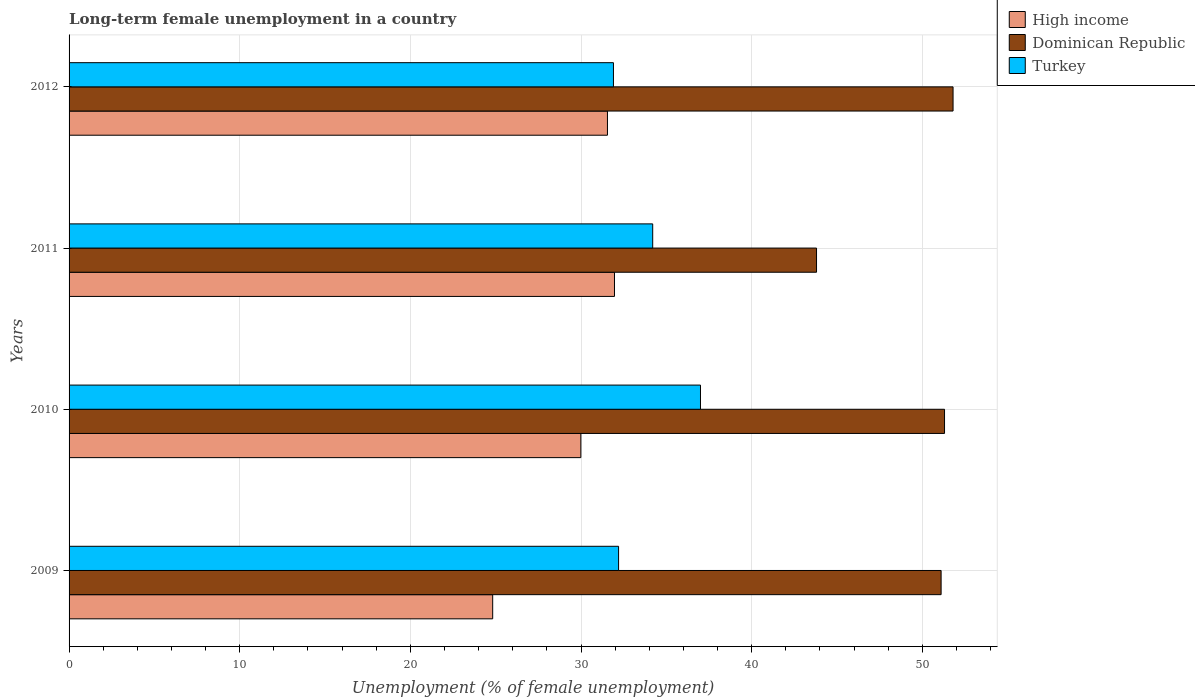How many groups of bars are there?
Offer a very short reply. 4. Are the number of bars on each tick of the Y-axis equal?
Make the answer very short. Yes. How many bars are there on the 2nd tick from the top?
Provide a succinct answer. 3. In how many cases, is the number of bars for a given year not equal to the number of legend labels?
Offer a very short reply. 0. What is the percentage of long-term unemployed female population in Dominican Republic in 2010?
Offer a terse response. 51.3. Across all years, what is the maximum percentage of long-term unemployed female population in High income?
Provide a short and direct response. 31.96. Across all years, what is the minimum percentage of long-term unemployed female population in High income?
Ensure brevity in your answer.  24.82. In which year was the percentage of long-term unemployed female population in Dominican Republic maximum?
Give a very brief answer. 2012. What is the total percentage of long-term unemployed female population in Dominican Republic in the graph?
Make the answer very short. 198. What is the difference between the percentage of long-term unemployed female population in Dominican Republic in 2009 and that in 2012?
Your answer should be very brief. -0.7. What is the difference between the percentage of long-term unemployed female population in Turkey in 2010 and the percentage of long-term unemployed female population in High income in 2011?
Your answer should be compact. 5.04. What is the average percentage of long-term unemployed female population in Turkey per year?
Your answer should be compact. 33.83. In the year 2012, what is the difference between the percentage of long-term unemployed female population in Turkey and percentage of long-term unemployed female population in High income?
Give a very brief answer. 0.35. In how many years, is the percentage of long-term unemployed female population in High income greater than 10 %?
Ensure brevity in your answer.  4. What is the ratio of the percentage of long-term unemployed female population in High income in 2010 to that in 2012?
Make the answer very short. 0.95. Is the percentage of long-term unemployed female population in Turkey in 2011 less than that in 2012?
Offer a terse response. No. Is the difference between the percentage of long-term unemployed female population in Turkey in 2010 and 2012 greater than the difference between the percentage of long-term unemployed female population in High income in 2010 and 2012?
Your answer should be compact. Yes. Is the sum of the percentage of long-term unemployed female population in High income in 2010 and 2011 greater than the maximum percentage of long-term unemployed female population in Turkey across all years?
Offer a terse response. Yes. What does the 2nd bar from the bottom in 2012 represents?
Ensure brevity in your answer.  Dominican Republic. How many bars are there?
Your answer should be very brief. 12. How many years are there in the graph?
Ensure brevity in your answer.  4. What is the difference between two consecutive major ticks on the X-axis?
Your response must be concise. 10. Does the graph contain grids?
Your response must be concise. Yes. Where does the legend appear in the graph?
Offer a terse response. Top right. How many legend labels are there?
Make the answer very short. 3. What is the title of the graph?
Your answer should be compact. Long-term female unemployment in a country. What is the label or title of the X-axis?
Give a very brief answer. Unemployment (% of female unemployment). What is the label or title of the Y-axis?
Offer a very short reply. Years. What is the Unemployment (% of female unemployment) in High income in 2009?
Offer a terse response. 24.82. What is the Unemployment (% of female unemployment) of Dominican Republic in 2009?
Your answer should be very brief. 51.1. What is the Unemployment (% of female unemployment) of Turkey in 2009?
Provide a succinct answer. 32.2. What is the Unemployment (% of female unemployment) of High income in 2010?
Provide a succinct answer. 29.99. What is the Unemployment (% of female unemployment) in Dominican Republic in 2010?
Provide a succinct answer. 51.3. What is the Unemployment (% of female unemployment) in High income in 2011?
Provide a short and direct response. 31.96. What is the Unemployment (% of female unemployment) in Dominican Republic in 2011?
Keep it short and to the point. 43.8. What is the Unemployment (% of female unemployment) in Turkey in 2011?
Ensure brevity in your answer.  34.2. What is the Unemployment (% of female unemployment) in High income in 2012?
Provide a succinct answer. 31.55. What is the Unemployment (% of female unemployment) in Dominican Republic in 2012?
Make the answer very short. 51.8. What is the Unemployment (% of female unemployment) in Turkey in 2012?
Offer a very short reply. 31.9. Across all years, what is the maximum Unemployment (% of female unemployment) in High income?
Keep it short and to the point. 31.96. Across all years, what is the maximum Unemployment (% of female unemployment) in Dominican Republic?
Your answer should be very brief. 51.8. Across all years, what is the maximum Unemployment (% of female unemployment) of Turkey?
Offer a terse response. 37. Across all years, what is the minimum Unemployment (% of female unemployment) in High income?
Your answer should be compact. 24.82. Across all years, what is the minimum Unemployment (% of female unemployment) of Dominican Republic?
Give a very brief answer. 43.8. Across all years, what is the minimum Unemployment (% of female unemployment) of Turkey?
Ensure brevity in your answer.  31.9. What is the total Unemployment (% of female unemployment) of High income in the graph?
Offer a very short reply. 118.32. What is the total Unemployment (% of female unemployment) of Dominican Republic in the graph?
Keep it short and to the point. 198. What is the total Unemployment (% of female unemployment) in Turkey in the graph?
Make the answer very short. 135.3. What is the difference between the Unemployment (% of female unemployment) in High income in 2009 and that in 2010?
Your response must be concise. -5.17. What is the difference between the Unemployment (% of female unemployment) of Turkey in 2009 and that in 2010?
Keep it short and to the point. -4.8. What is the difference between the Unemployment (% of female unemployment) in High income in 2009 and that in 2011?
Provide a short and direct response. -7.14. What is the difference between the Unemployment (% of female unemployment) in Turkey in 2009 and that in 2011?
Ensure brevity in your answer.  -2. What is the difference between the Unemployment (% of female unemployment) of High income in 2009 and that in 2012?
Offer a terse response. -6.73. What is the difference between the Unemployment (% of female unemployment) in Turkey in 2009 and that in 2012?
Your answer should be very brief. 0.3. What is the difference between the Unemployment (% of female unemployment) in High income in 2010 and that in 2011?
Your response must be concise. -1.97. What is the difference between the Unemployment (% of female unemployment) of High income in 2010 and that in 2012?
Make the answer very short. -1.56. What is the difference between the Unemployment (% of female unemployment) in Dominican Republic in 2010 and that in 2012?
Provide a short and direct response. -0.5. What is the difference between the Unemployment (% of female unemployment) of High income in 2011 and that in 2012?
Ensure brevity in your answer.  0.41. What is the difference between the Unemployment (% of female unemployment) of Dominican Republic in 2011 and that in 2012?
Your answer should be compact. -8. What is the difference between the Unemployment (% of female unemployment) in Turkey in 2011 and that in 2012?
Your answer should be compact. 2.3. What is the difference between the Unemployment (% of female unemployment) in High income in 2009 and the Unemployment (% of female unemployment) in Dominican Republic in 2010?
Your answer should be compact. -26.48. What is the difference between the Unemployment (% of female unemployment) of High income in 2009 and the Unemployment (% of female unemployment) of Turkey in 2010?
Provide a succinct answer. -12.18. What is the difference between the Unemployment (% of female unemployment) of Dominican Republic in 2009 and the Unemployment (% of female unemployment) of Turkey in 2010?
Provide a short and direct response. 14.1. What is the difference between the Unemployment (% of female unemployment) of High income in 2009 and the Unemployment (% of female unemployment) of Dominican Republic in 2011?
Offer a very short reply. -18.98. What is the difference between the Unemployment (% of female unemployment) of High income in 2009 and the Unemployment (% of female unemployment) of Turkey in 2011?
Make the answer very short. -9.38. What is the difference between the Unemployment (% of female unemployment) of Dominican Republic in 2009 and the Unemployment (% of female unemployment) of Turkey in 2011?
Your answer should be very brief. 16.9. What is the difference between the Unemployment (% of female unemployment) of High income in 2009 and the Unemployment (% of female unemployment) of Dominican Republic in 2012?
Your answer should be compact. -26.98. What is the difference between the Unemployment (% of female unemployment) of High income in 2009 and the Unemployment (% of female unemployment) of Turkey in 2012?
Your response must be concise. -7.08. What is the difference between the Unemployment (% of female unemployment) of Dominican Republic in 2009 and the Unemployment (% of female unemployment) of Turkey in 2012?
Make the answer very short. 19.2. What is the difference between the Unemployment (% of female unemployment) in High income in 2010 and the Unemployment (% of female unemployment) in Dominican Republic in 2011?
Provide a short and direct response. -13.81. What is the difference between the Unemployment (% of female unemployment) of High income in 2010 and the Unemployment (% of female unemployment) of Turkey in 2011?
Provide a short and direct response. -4.21. What is the difference between the Unemployment (% of female unemployment) in High income in 2010 and the Unemployment (% of female unemployment) in Dominican Republic in 2012?
Your answer should be compact. -21.81. What is the difference between the Unemployment (% of female unemployment) of High income in 2010 and the Unemployment (% of female unemployment) of Turkey in 2012?
Ensure brevity in your answer.  -1.91. What is the difference between the Unemployment (% of female unemployment) of High income in 2011 and the Unemployment (% of female unemployment) of Dominican Republic in 2012?
Your answer should be very brief. -19.84. What is the difference between the Unemployment (% of female unemployment) of High income in 2011 and the Unemployment (% of female unemployment) of Turkey in 2012?
Offer a terse response. 0.06. What is the difference between the Unemployment (% of female unemployment) in Dominican Republic in 2011 and the Unemployment (% of female unemployment) in Turkey in 2012?
Make the answer very short. 11.9. What is the average Unemployment (% of female unemployment) of High income per year?
Your response must be concise. 29.58. What is the average Unemployment (% of female unemployment) of Dominican Republic per year?
Ensure brevity in your answer.  49.5. What is the average Unemployment (% of female unemployment) of Turkey per year?
Make the answer very short. 33.83. In the year 2009, what is the difference between the Unemployment (% of female unemployment) in High income and Unemployment (% of female unemployment) in Dominican Republic?
Provide a short and direct response. -26.28. In the year 2009, what is the difference between the Unemployment (% of female unemployment) of High income and Unemployment (% of female unemployment) of Turkey?
Keep it short and to the point. -7.38. In the year 2009, what is the difference between the Unemployment (% of female unemployment) in Dominican Republic and Unemployment (% of female unemployment) in Turkey?
Give a very brief answer. 18.9. In the year 2010, what is the difference between the Unemployment (% of female unemployment) of High income and Unemployment (% of female unemployment) of Dominican Republic?
Your answer should be compact. -21.31. In the year 2010, what is the difference between the Unemployment (% of female unemployment) of High income and Unemployment (% of female unemployment) of Turkey?
Provide a short and direct response. -7.01. In the year 2010, what is the difference between the Unemployment (% of female unemployment) of Dominican Republic and Unemployment (% of female unemployment) of Turkey?
Offer a terse response. 14.3. In the year 2011, what is the difference between the Unemployment (% of female unemployment) of High income and Unemployment (% of female unemployment) of Dominican Republic?
Ensure brevity in your answer.  -11.84. In the year 2011, what is the difference between the Unemployment (% of female unemployment) of High income and Unemployment (% of female unemployment) of Turkey?
Make the answer very short. -2.24. In the year 2012, what is the difference between the Unemployment (% of female unemployment) of High income and Unemployment (% of female unemployment) of Dominican Republic?
Keep it short and to the point. -20.25. In the year 2012, what is the difference between the Unemployment (% of female unemployment) of High income and Unemployment (% of female unemployment) of Turkey?
Make the answer very short. -0.35. In the year 2012, what is the difference between the Unemployment (% of female unemployment) of Dominican Republic and Unemployment (% of female unemployment) of Turkey?
Offer a very short reply. 19.9. What is the ratio of the Unemployment (% of female unemployment) of High income in 2009 to that in 2010?
Give a very brief answer. 0.83. What is the ratio of the Unemployment (% of female unemployment) in Dominican Republic in 2009 to that in 2010?
Offer a terse response. 1. What is the ratio of the Unemployment (% of female unemployment) in Turkey in 2009 to that in 2010?
Give a very brief answer. 0.87. What is the ratio of the Unemployment (% of female unemployment) of High income in 2009 to that in 2011?
Your answer should be compact. 0.78. What is the ratio of the Unemployment (% of female unemployment) of Dominican Republic in 2009 to that in 2011?
Your answer should be compact. 1.17. What is the ratio of the Unemployment (% of female unemployment) of Turkey in 2009 to that in 2011?
Provide a succinct answer. 0.94. What is the ratio of the Unemployment (% of female unemployment) in High income in 2009 to that in 2012?
Keep it short and to the point. 0.79. What is the ratio of the Unemployment (% of female unemployment) in Dominican Republic in 2009 to that in 2012?
Your answer should be compact. 0.99. What is the ratio of the Unemployment (% of female unemployment) in Turkey in 2009 to that in 2012?
Provide a short and direct response. 1.01. What is the ratio of the Unemployment (% of female unemployment) of High income in 2010 to that in 2011?
Keep it short and to the point. 0.94. What is the ratio of the Unemployment (% of female unemployment) in Dominican Republic in 2010 to that in 2011?
Your response must be concise. 1.17. What is the ratio of the Unemployment (% of female unemployment) in Turkey in 2010 to that in 2011?
Provide a short and direct response. 1.08. What is the ratio of the Unemployment (% of female unemployment) of High income in 2010 to that in 2012?
Your answer should be compact. 0.95. What is the ratio of the Unemployment (% of female unemployment) in Dominican Republic in 2010 to that in 2012?
Offer a terse response. 0.99. What is the ratio of the Unemployment (% of female unemployment) of Turkey in 2010 to that in 2012?
Offer a terse response. 1.16. What is the ratio of the Unemployment (% of female unemployment) in High income in 2011 to that in 2012?
Provide a succinct answer. 1.01. What is the ratio of the Unemployment (% of female unemployment) of Dominican Republic in 2011 to that in 2012?
Offer a terse response. 0.85. What is the ratio of the Unemployment (% of female unemployment) of Turkey in 2011 to that in 2012?
Offer a very short reply. 1.07. What is the difference between the highest and the second highest Unemployment (% of female unemployment) in High income?
Keep it short and to the point. 0.41. What is the difference between the highest and the second highest Unemployment (% of female unemployment) of Dominican Republic?
Provide a short and direct response. 0.5. What is the difference between the highest and the second highest Unemployment (% of female unemployment) in Turkey?
Your answer should be very brief. 2.8. What is the difference between the highest and the lowest Unemployment (% of female unemployment) of High income?
Provide a short and direct response. 7.14. What is the difference between the highest and the lowest Unemployment (% of female unemployment) of Dominican Republic?
Offer a terse response. 8. 